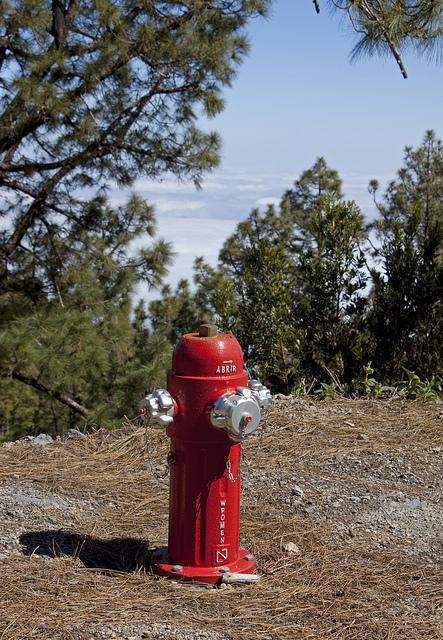What kind of tree is this?
Write a very short answer. Pine. Is this fire hydrant red?
Quick response, please. Yes. What color is the hydrant?
Concise answer only. Red. How is the sky?
Write a very short answer. Cloudy. Is this in a city?
Write a very short answer. No. Is the grass green?
Short answer required. No. Is there a shadow?
Write a very short answer. Yes. Is the fire hydrant new or old?
Give a very brief answer. New. 